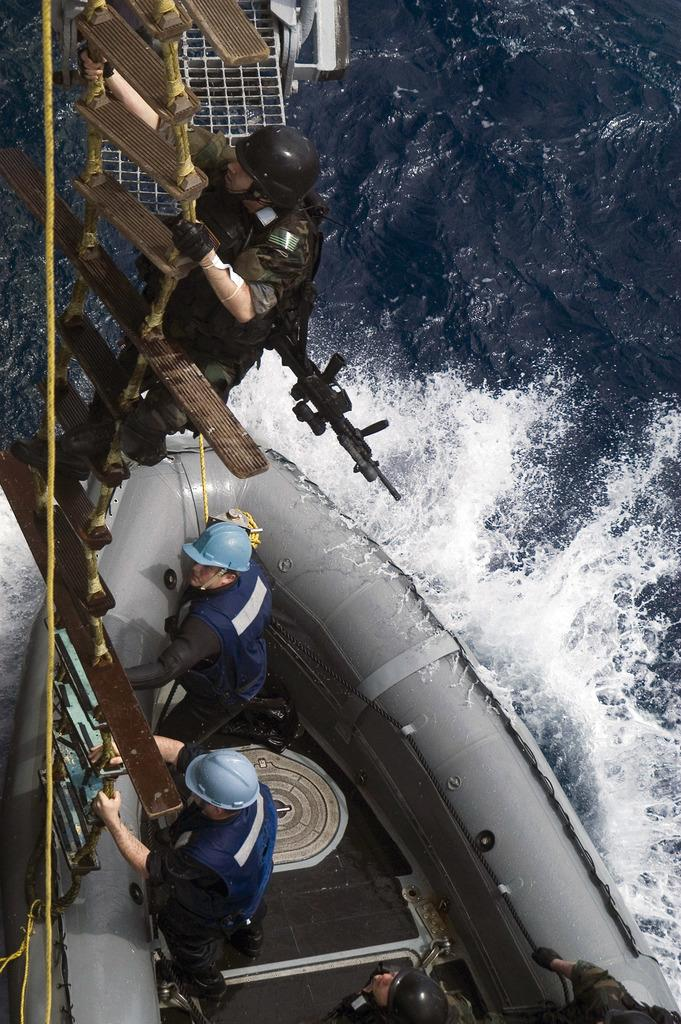What are the people in the image doing? There are persons on a boat in the image, and one person is climbing a rope ladder. What can be seen in the background of the image? There is water visible in the image. Are there any other objects present in the image besides the boat and the people? Yes, there are other objects present in the image. What type of glass is being used to catch the gold falling from the sky in the image? There is no glass or gold falling from the sky in the image; it features persons on a boat and one person climbing a rope ladder. 